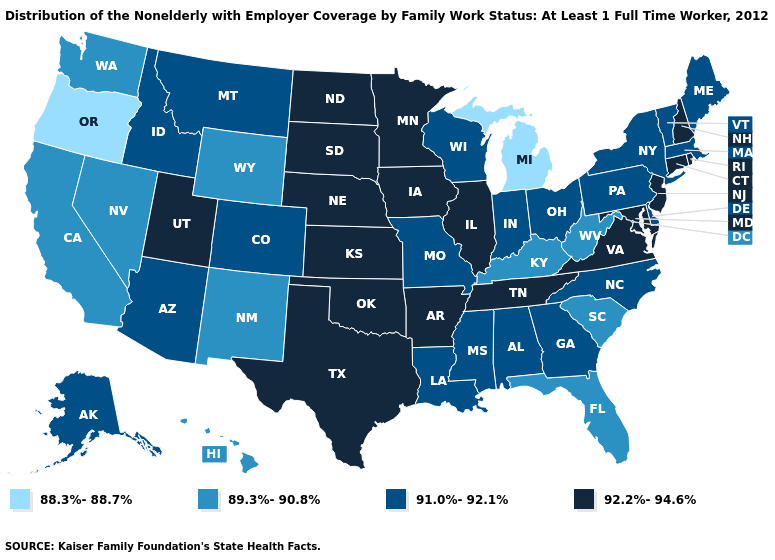What is the value of Montana?
Concise answer only. 91.0%-92.1%. What is the highest value in the USA?
Write a very short answer. 92.2%-94.6%. Does New Hampshire have the lowest value in the Northeast?
Write a very short answer. No. What is the value of Connecticut?
Give a very brief answer. 92.2%-94.6%. What is the value of Wyoming?
Be succinct. 89.3%-90.8%. What is the highest value in states that border Illinois?
Concise answer only. 92.2%-94.6%. Name the states that have a value in the range 91.0%-92.1%?
Quick response, please. Alabama, Alaska, Arizona, Colorado, Delaware, Georgia, Idaho, Indiana, Louisiana, Maine, Massachusetts, Mississippi, Missouri, Montana, New York, North Carolina, Ohio, Pennsylvania, Vermont, Wisconsin. What is the highest value in the South ?
Give a very brief answer. 92.2%-94.6%. What is the highest value in the Northeast ?
Answer briefly. 92.2%-94.6%. Name the states that have a value in the range 92.2%-94.6%?
Answer briefly. Arkansas, Connecticut, Illinois, Iowa, Kansas, Maryland, Minnesota, Nebraska, New Hampshire, New Jersey, North Dakota, Oklahoma, Rhode Island, South Dakota, Tennessee, Texas, Utah, Virginia. Does the map have missing data?
Be succinct. No. What is the value of Arkansas?
Short answer required. 92.2%-94.6%. Which states have the lowest value in the MidWest?
Be succinct. Michigan. What is the highest value in the West ?
Keep it brief. 92.2%-94.6%. Does Vermont have the highest value in the Northeast?
Give a very brief answer. No. 